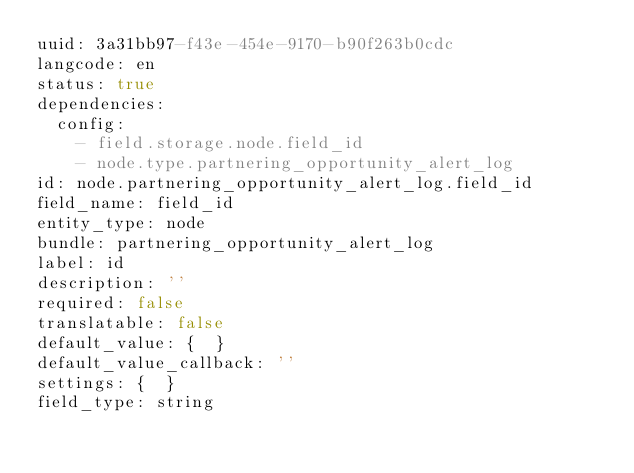Convert code to text. <code><loc_0><loc_0><loc_500><loc_500><_YAML_>uuid: 3a31bb97-f43e-454e-9170-b90f263b0cdc
langcode: en
status: true
dependencies:
  config:
    - field.storage.node.field_id
    - node.type.partnering_opportunity_alert_log
id: node.partnering_opportunity_alert_log.field_id
field_name: field_id
entity_type: node
bundle: partnering_opportunity_alert_log
label: id
description: ''
required: false
translatable: false
default_value: {  }
default_value_callback: ''
settings: {  }
field_type: string
</code> 